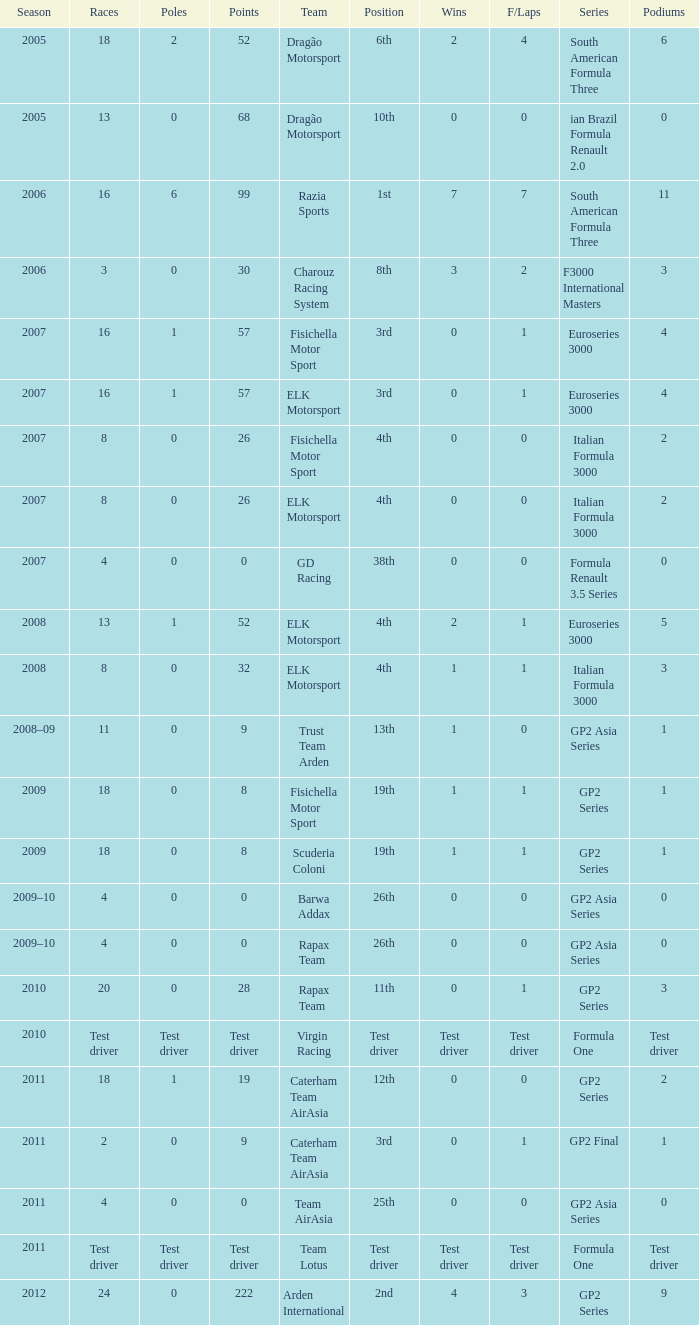What were the points in the year when his Wins were 0, his Podiums were 0, and he drove in 4 races? 0, 0, 0, 0. 